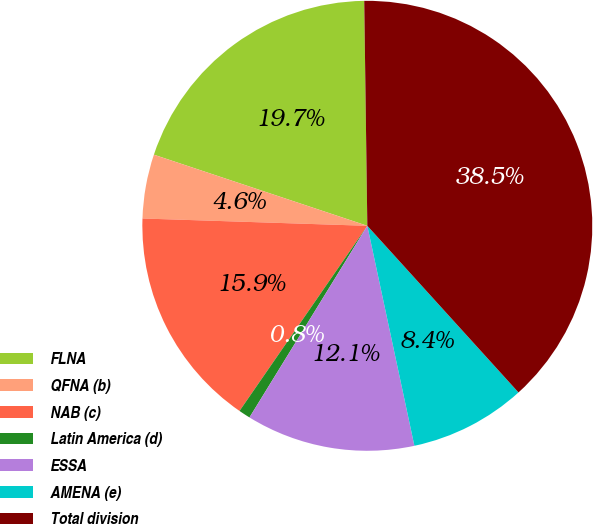<chart> <loc_0><loc_0><loc_500><loc_500><pie_chart><fcel>FLNA<fcel>QFNA (b)<fcel>NAB (c)<fcel>Latin America (d)<fcel>ESSA<fcel>AMENA (e)<fcel>Total division<nl><fcel>19.66%<fcel>4.6%<fcel>15.9%<fcel>0.84%<fcel>12.13%<fcel>8.37%<fcel>38.49%<nl></chart> 